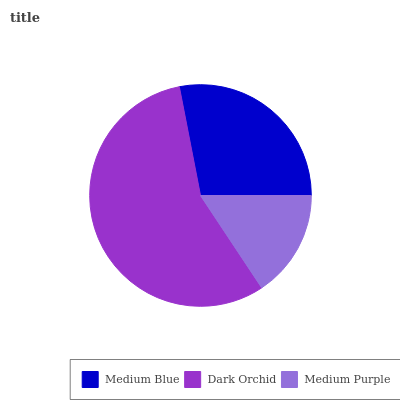Is Medium Purple the minimum?
Answer yes or no. Yes. Is Dark Orchid the maximum?
Answer yes or no. Yes. Is Dark Orchid the minimum?
Answer yes or no. No. Is Medium Purple the maximum?
Answer yes or no. No. Is Dark Orchid greater than Medium Purple?
Answer yes or no. Yes. Is Medium Purple less than Dark Orchid?
Answer yes or no. Yes. Is Medium Purple greater than Dark Orchid?
Answer yes or no. No. Is Dark Orchid less than Medium Purple?
Answer yes or no. No. Is Medium Blue the high median?
Answer yes or no. Yes. Is Medium Blue the low median?
Answer yes or no. Yes. Is Medium Purple the high median?
Answer yes or no. No. Is Medium Purple the low median?
Answer yes or no. No. 